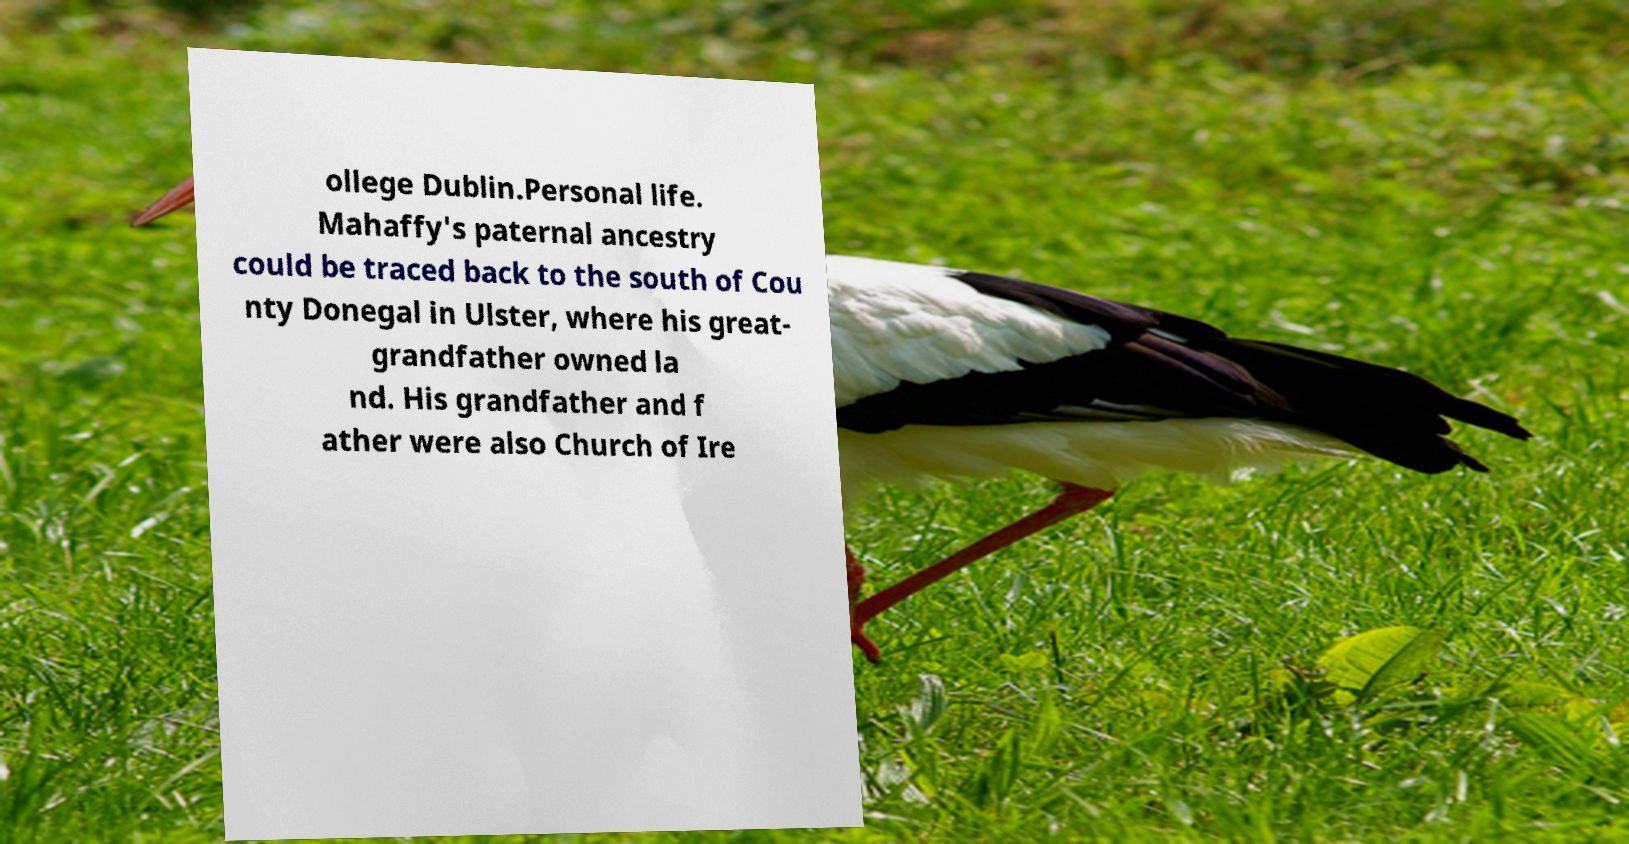Please read and relay the text visible in this image. What does it say? ollege Dublin.Personal life. Mahaffy's paternal ancestry could be traced back to the south of Cou nty Donegal in Ulster, where his great- grandfather owned la nd. His grandfather and f ather were also Church of Ire 